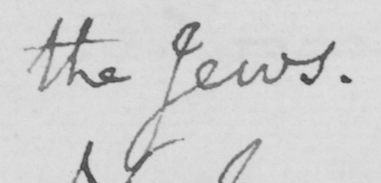Can you read and transcribe this handwriting? the Jews . 